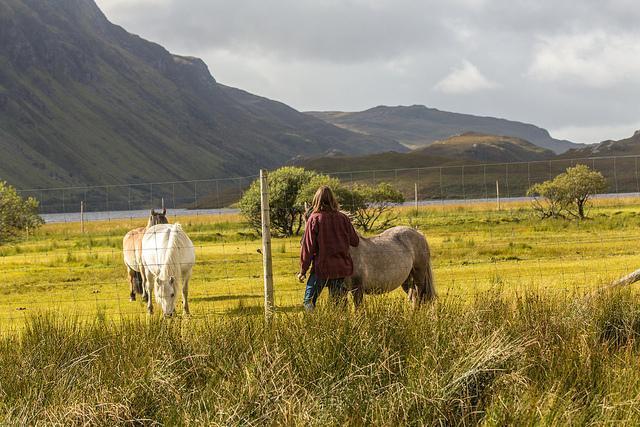How many horses can you see?
Give a very brief answer. 2. How many programs does this laptop have installed?
Give a very brief answer. 0. 